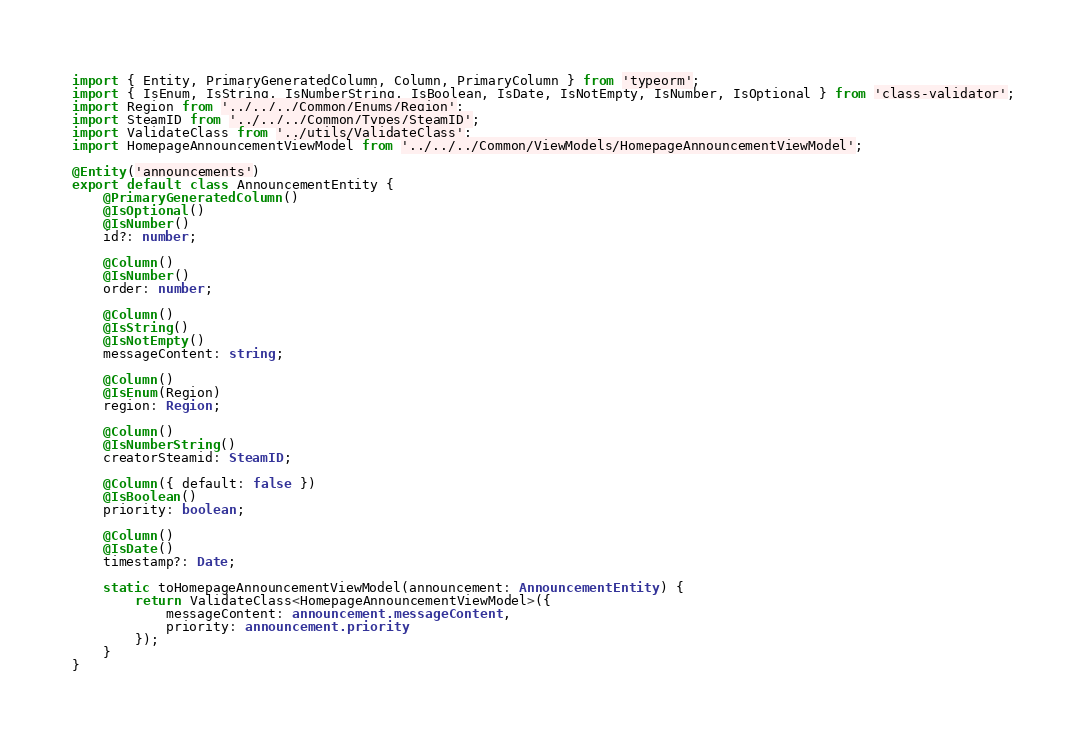<code> <loc_0><loc_0><loc_500><loc_500><_TypeScript_>import { Entity, PrimaryGeneratedColumn, Column, PrimaryColumn } from 'typeorm';
import { IsEnum, IsString, IsNumberString, IsBoolean, IsDate, IsNotEmpty, IsNumber, IsOptional } from 'class-validator';
import Region from '../../../Common/Enums/Region';
import SteamID from '../../../Common/Types/SteamID';
import ValidateClass from '../utils/ValidateClass';
import HomepageAnnouncementViewModel from '../../../Common/ViewModels/HomepageAnnouncementViewModel';

@Entity('announcements')
export default class AnnouncementEntity {
	@PrimaryGeneratedColumn()
	@IsOptional()
	@IsNumber()
	id?: number;

	@Column()
	@IsNumber()
	order: number;

	@Column()
	@IsString()
	@IsNotEmpty()
	messageContent: string;

	@Column()
	@IsEnum(Region)
	region: Region;

	@Column()
	@IsNumberString()
	creatorSteamid: SteamID;

	@Column({ default: false })
	@IsBoolean()
	priority: boolean;

	@Column()
	@IsDate()
	timestamp?: Date;

	static toHomepageAnnouncementViewModel(announcement: AnnouncementEntity) {
		return ValidateClass<HomepageAnnouncementViewModel>({
			messageContent: announcement.messageContent,
			priority: announcement.priority
		});
	}
}
</code> 